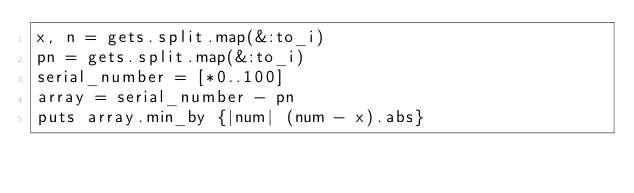<code> <loc_0><loc_0><loc_500><loc_500><_Ruby_>x, n = gets.split.map(&:to_i)
pn = gets.split.map(&:to_i)
serial_number = [*0..100]
array = serial_number - pn
puts array.min_by {|num| (num - x).abs}
</code> 